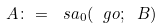<formula> <loc_0><loc_0><loc_500><loc_500>A \colon = \ s a _ { 0 } ( \ g o ; \ B )</formula> 